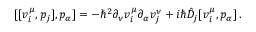Convert formula to latex. <formula><loc_0><loc_0><loc_500><loc_500>[ [ v _ { i } ^ { \mu } , p _ { j } ] , p _ { \alpha } ] = - \hbar { ^ } { 2 } \partial _ { \nu } v _ { i } ^ { \mu } \partial _ { \alpha } v _ { j } ^ { \nu } + i \hbar { \hat } { D } _ { j } [ v _ { i } ^ { \mu } , p _ { \alpha } ] \, .</formula> 